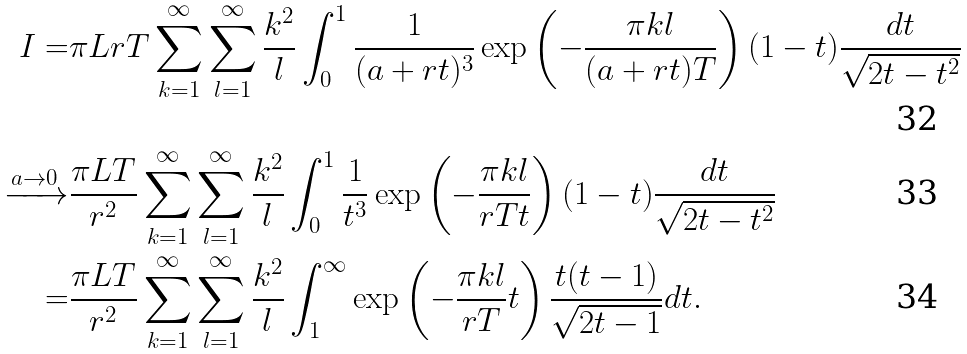Convert formula to latex. <formula><loc_0><loc_0><loc_500><loc_500>I = & \pi L r T \sum _ { k = 1 } ^ { \infty } \sum _ { l = 1 } ^ { \infty } \frac { k ^ { 2 } } { l } \int _ { 0 } ^ { 1 } \frac { 1 } { ( a + r t ) ^ { 3 } } \exp \left ( - \frac { \pi k l } { ( a + r t ) T } \right ) ( 1 - t ) \frac { d t } { \sqrt { 2 t - t ^ { 2 } } } \\ \xrightarrow { a \rightarrow 0 } & \frac { \pi L T } { r ^ { 2 } } \sum _ { k = 1 } ^ { \infty } \sum _ { l = 1 } ^ { \infty } \frac { k ^ { 2 } } { l } \int _ { 0 } ^ { 1 } \frac { 1 } { t ^ { 3 } } \exp \left ( - \frac { \pi k l } { r T t } \right ) ( 1 - t ) \frac { d t } { \sqrt { 2 t - t ^ { 2 } } } \\ = & \frac { \pi L T } { r ^ { 2 } } \sum _ { k = 1 } ^ { \infty } \sum _ { l = 1 } ^ { \infty } \frac { k ^ { 2 } } { l } \int _ { 1 } ^ { \infty } \exp \left ( - \frac { \pi k l } { r T } t \right ) \frac { t ( t - 1 ) } { \sqrt { 2 t - 1 } } d t .</formula> 